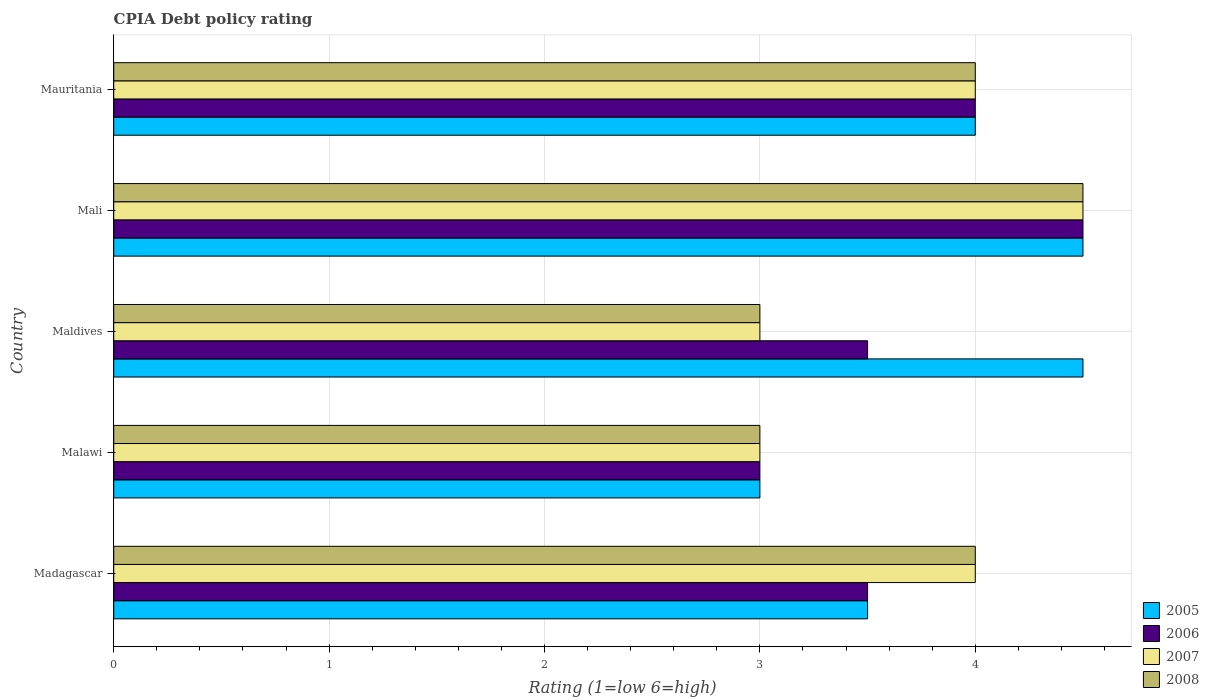How many different coloured bars are there?
Offer a very short reply. 4. What is the label of the 5th group of bars from the top?
Your answer should be compact. Madagascar. In how many cases, is the number of bars for a given country not equal to the number of legend labels?
Offer a very short reply. 0. What is the CPIA rating in 2007 in Malawi?
Your answer should be very brief. 3. Across all countries, what is the minimum CPIA rating in 2006?
Offer a terse response. 3. In which country was the CPIA rating in 2007 maximum?
Your answer should be compact. Mali. In which country was the CPIA rating in 2005 minimum?
Your response must be concise. Malawi. What is the difference between the CPIA rating in 2007 in Malawi and that in Mauritania?
Offer a terse response. -1. What is the difference between the CPIA rating in 2007 in Mauritania and the CPIA rating in 2006 in Maldives?
Make the answer very short. 0.5. What is the average CPIA rating in 2008 per country?
Provide a short and direct response. 3.7. In how many countries, is the CPIA rating in 2008 greater than 1 ?
Offer a terse response. 5. What is the ratio of the CPIA rating in 2007 in Maldives to that in Mauritania?
Give a very brief answer. 0.75. What is the difference between the highest and the lowest CPIA rating in 2008?
Offer a terse response. 1.5. In how many countries, is the CPIA rating in 2007 greater than the average CPIA rating in 2007 taken over all countries?
Your answer should be compact. 3. Is the sum of the CPIA rating in 2006 in Madagascar and Maldives greater than the maximum CPIA rating in 2008 across all countries?
Make the answer very short. Yes. Is it the case that in every country, the sum of the CPIA rating in 2005 and CPIA rating in 2007 is greater than the sum of CPIA rating in 2006 and CPIA rating in 2008?
Your response must be concise. No. What does the 1st bar from the top in Mauritania represents?
Keep it short and to the point. 2008. Is it the case that in every country, the sum of the CPIA rating in 2005 and CPIA rating in 2006 is greater than the CPIA rating in 2008?
Ensure brevity in your answer.  Yes. How many bars are there?
Offer a terse response. 20. How many countries are there in the graph?
Offer a very short reply. 5. What is the difference between two consecutive major ticks on the X-axis?
Your answer should be very brief. 1. Are the values on the major ticks of X-axis written in scientific E-notation?
Provide a succinct answer. No. Where does the legend appear in the graph?
Provide a short and direct response. Bottom right. How are the legend labels stacked?
Your response must be concise. Vertical. What is the title of the graph?
Offer a very short reply. CPIA Debt policy rating. What is the Rating (1=low 6=high) in 2005 in Madagascar?
Give a very brief answer. 3.5. What is the Rating (1=low 6=high) in 2006 in Madagascar?
Offer a very short reply. 3.5. What is the Rating (1=low 6=high) of 2007 in Madagascar?
Make the answer very short. 4. What is the Rating (1=low 6=high) of 2007 in Maldives?
Make the answer very short. 3. What is the Rating (1=low 6=high) in 2008 in Maldives?
Provide a succinct answer. 3. What is the Rating (1=low 6=high) of 2005 in Mali?
Offer a terse response. 4.5. What is the Rating (1=low 6=high) of 2007 in Mali?
Ensure brevity in your answer.  4.5. What is the Rating (1=low 6=high) in 2008 in Mali?
Provide a short and direct response. 4.5. What is the Rating (1=low 6=high) in 2007 in Mauritania?
Offer a very short reply. 4. What is the Rating (1=low 6=high) in 2008 in Mauritania?
Provide a short and direct response. 4. Across all countries, what is the maximum Rating (1=low 6=high) in 2005?
Provide a succinct answer. 4.5. Across all countries, what is the maximum Rating (1=low 6=high) of 2006?
Your answer should be very brief. 4.5. Across all countries, what is the minimum Rating (1=low 6=high) of 2005?
Provide a succinct answer. 3. Across all countries, what is the minimum Rating (1=low 6=high) of 2008?
Your answer should be compact. 3. What is the total Rating (1=low 6=high) of 2006 in the graph?
Offer a very short reply. 18.5. What is the total Rating (1=low 6=high) in 2008 in the graph?
Provide a short and direct response. 18.5. What is the difference between the Rating (1=low 6=high) in 2007 in Madagascar and that in Malawi?
Your answer should be very brief. 1. What is the difference between the Rating (1=low 6=high) in 2007 in Madagascar and that in Maldives?
Make the answer very short. 1. What is the difference between the Rating (1=low 6=high) in 2008 in Madagascar and that in Maldives?
Your answer should be very brief. 1. What is the difference between the Rating (1=low 6=high) of 2006 in Madagascar and that in Mali?
Give a very brief answer. -1. What is the difference between the Rating (1=low 6=high) in 2007 in Madagascar and that in Mali?
Make the answer very short. -0.5. What is the difference between the Rating (1=low 6=high) in 2008 in Madagascar and that in Mali?
Your answer should be very brief. -0.5. What is the difference between the Rating (1=low 6=high) in 2005 in Madagascar and that in Mauritania?
Keep it short and to the point. -0.5. What is the difference between the Rating (1=low 6=high) in 2006 in Madagascar and that in Mauritania?
Provide a succinct answer. -0.5. What is the difference between the Rating (1=low 6=high) in 2007 in Madagascar and that in Mauritania?
Offer a terse response. 0. What is the difference between the Rating (1=low 6=high) in 2005 in Malawi and that in Maldives?
Ensure brevity in your answer.  -1.5. What is the difference between the Rating (1=low 6=high) in 2006 in Malawi and that in Maldives?
Offer a very short reply. -0.5. What is the difference between the Rating (1=low 6=high) of 2007 in Malawi and that in Maldives?
Your answer should be very brief. 0. What is the difference between the Rating (1=low 6=high) in 2008 in Malawi and that in Maldives?
Provide a short and direct response. 0. What is the difference between the Rating (1=low 6=high) in 2005 in Malawi and that in Mali?
Offer a terse response. -1.5. What is the difference between the Rating (1=low 6=high) of 2006 in Malawi and that in Mali?
Provide a short and direct response. -1.5. What is the difference between the Rating (1=low 6=high) of 2007 in Malawi and that in Mali?
Keep it short and to the point. -1.5. What is the difference between the Rating (1=low 6=high) in 2008 in Malawi and that in Mali?
Ensure brevity in your answer.  -1.5. What is the difference between the Rating (1=low 6=high) of 2005 in Malawi and that in Mauritania?
Offer a terse response. -1. What is the difference between the Rating (1=low 6=high) of 2007 in Malawi and that in Mauritania?
Your answer should be very brief. -1. What is the difference between the Rating (1=low 6=high) in 2005 in Maldives and that in Mali?
Your response must be concise. 0. What is the difference between the Rating (1=low 6=high) in 2006 in Maldives and that in Mali?
Your response must be concise. -1. What is the difference between the Rating (1=low 6=high) of 2008 in Maldives and that in Mali?
Your response must be concise. -1.5. What is the difference between the Rating (1=low 6=high) in 2005 in Maldives and that in Mauritania?
Offer a terse response. 0.5. What is the difference between the Rating (1=low 6=high) of 2007 in Maldives and that in Mauritania?
Provide a short and direct response. -1. What is the difference between the Rating (1=low 6=high) in 2005 in Madagascar and the Rating (1=low 6=high) in 2006 in Malawi?
Offer a terse response. 0.5. What is the difference between the Rating (1=low 6=high) of 2005 in Madagascar and the Rating (1=low 6=high) of 2007 in Malawi?
Offer a terse response. 0.5. What is the difference between the Rating (1=low 6=high) of 2005 in Madagascar and the Rating (1=low 6=high) of 2008 in Malawi?
Provide a short and direct response. 0.5. What is the difference between the Rating (1=low 6=high) of 2006 in Madagascar and the Rating (1=low 6=high) of 2007 in Malawi?
Your answer should be compact. 0.5. What is the difference between the Rating (1=low 6=high) in 2005 in Madagascar and the Rating (1=low 6=high) in 2008 in Maldives?
Your response must be concise. 0.5. What is the difference between the Rating (1=low 6=high) in 2006 in Madagascar and the Rating (1=low 6=high) in 2007 in Maldives?
Ensure brevity in your answer.  0.5. What is the difference between the Rating (1=low 6=high) in 2007 in Madagascar and the Rating (1=low 6=high) in 2008 in Maldives?
Offer a terse response. 1. What is the difference between the Rating (1=low 6=high) of 2005 in Madagascar and the Rating (1=low 6=high) of 2007 in Mali?
Your answer should be very brief. -1. What is the difference between the Rating (1=low 6=high) of 2006 in Madagascar and the Rating (1=low 6=high) of 2007 in Mali?
Give a very brief answer. -1. What is the difference between the Rating (1=low 6=high) of 2006 in Madagascar and the Rating (1=low 6=high) of 2008 in Mali?
Offer a terse response. -1. What is the difference between the Rating (1=low 6=high) in 2007 in Madagascar and the Rating (1=low 6=high) in 2008 in Mali?
Your response must be concise. -0.5. What is the difference between the Rating (1=low 6=high) in 2005 in Madagascar and the Rating (1=low 6=high) in 2006 in Mauritania?
Offer a very short reply. -0.5. What is the difference between the Rating (1=low 6=high) of 2005 in Madagascar and the Rating (1=low 6=high) of 2007 in Mauritania?
Provide a short and direct response. -0.5. What is the difference between the Rating (1=low 6=high) in 2005 in Madagascar and the Rating (1=low 6=high) in 2008 in Mauritania?
Offer a terse response. -0.5. What is the difference between the Rating (1=low 6=high) of 2006 in Madagascar and the Rating (1=low 6=high) of 2007 in Mauritania?
Your response must be concise. -0.5. What is the difference between the Rating (1=low 6=high) of 2006 in Madagascar and the Rating (1=low 6=high) of 2008 in Mauritania?
Your answer should be compact. -0.5. What is the difference between the Rating (1=low 6=high) of 2005 in Malawi and the Rating (1=low 6=high) of 2008 in Maldives?
Your answer should be compact. 0. What is the difference between the Rating (1=low 6=high) in 2006 in Malawi and the Rating (1=low 6=high) in 2007 in Maldives?
Give a very brief answer. 0. What is the difference between the Rating (1=low 6=high) of 2007 in Malawi and the Rating (1=low 6=high) of 2008 in Maldives?
Your response must be concise. 0. What is the difference between the Rating (1=low 6=high) in 2005 in Malawi and the Rating (1=low 6=high) in 2006 in Mali?
Your answer should be very brief. -1.5. What is the difference between the Rating (1=low 6=high) of 2005 in Malawi and the Rating (1=low 6=high) of 2007 in Mali?
Your response must be concise. -1.5. What is the difference between the Rating (1=low 6=high) of 2005 in Malawi and the Rating (1=low 6=high) of 2008 in Mali?
Provide a succinct answer. -1.5. What is the difference between the Rating (1=low 6=high) of 2006 in Malawi and the Rating (1=low 6=high) of 2007 in Mali?
Your response must be concise. -1.5. What is the difference between the Rating (1=low 6=high) in 2006 in Malawi and the Rating (1=low 6=high) in 2008 in Mali?
Provide a short and direct response. -1.5. What is the difference between the Rating (1=low 6=high) of 2007 in Malawi and the Rating (1=low 6=high) of 2008 in Mali?
Your answer should be very brief. -1.5. What is the difference between the Rating (1=low 6=high) in 2006 in Malawi and the Rating (1=low 6=high) in 2007 in Mauritania?
Give a very brief answer. -1. What is the difference between the Rating (1=low 6=high) in 2006 in Malawi and the Rating (1=low 6=high) in 2008 in Mauritania?
Offer a very short reply. -1. What is the difference between the Rating (1=low 6=high) in 2007 in Malawi and the Rating (1=low 6=high) in 2008 in Mauritania?
Make the answer very short. -1. What is the difference between the Rating (1=low 6=high) in 2005 in Maldives and the Rating (1=low 6=high) in 2006 in Mali?
Your answer should be compact. 0. What is the difference between the Rating (1=low 6=high) in 2006 in Maldives and the Rating (1=low 6=high) in 2007 in Mali?
Your answer should be compact. -1. What is the difference between the Rating (1=low 6=high) in 2005 in Maldives and the Rating (1=low 6=high) in 2006 in Mauritania?
Your answer should be very brief. 0.5. What is the difference between the Rating (1=low 6=high) in 2005 in Maldives and the Rating (1=low 6=high) in 2007 in Mauritania?
Make the answer very short. 0.5. What is the difference between the Rating (1=low 6=high) of 2005 in Maldives and the Rating (1=low 6=high) of 2008 in Mauritania?
Your answer should be compact. 0.5. What is the difference between the Rating (1=low 6=high) of 2006 in Maldives and the Rating (1=low 6=high) of 2008 in Mauritania?
Your response must be concise. -0.5. What is the difference between the Rating (1=low 6=high) in 2006 in Mali and the Rating (1=low 6=high) in 2007 in Mauritania?
Provide a short and direct response. 0.5. What is the difference between the Rating (1=low 6=high) in 2007 in Mali and the Rating (1=low 6=high) in 2008 in Mauritania?
Ensure brevity in your answer.  0.5. What is the average Rating (1=low 6=high) of 2005 per country?
Provide a short and direct response. 3.9. What is the average Rating (1=low 6=high) of 2007 per country?
Ensure brevity in your answer.  3.7. What is the average Rating (1=low 6=high) of 2008 per country?
Provide a succinct answer. 3.7. What is the difference between the Rating (1=low 6=high) in 2005 and Rating (1=low 6=high) in 2007 in Madagascar?
Your answer should be compact. -0.5. What is the difference between the Rating (1=low 6=high) of 2005 and Rating (1=low 6=high) of 2008 in Madagascar?
Make the answer very short. -0.5. What is the difference between the Rating (1=low 6=high) in 2006 and Rating (1=low 6=high) in 2007 in Madagascar?
Give a very brief answer. -0.5. What is the difference between the Rating (1=low 6=high) of 2007 and Rating (1=low 6=high) of 2008 in Madagascar?
Keep it short and to the point. 0. What is the difference between the Rating (1=low 6=high) of 2005 and Rating (1=low 6=high) of 2006 in Malawi?
Provide a succinct answer. 0. What is the difference between the Rating (1=low 6=high) of 2005 and Rating (1=low 6=high) of 2006 in Maldives?
Keep it short and to the point. 1. What is the difference between the Rating (1=low 6=high) of 2005 and Rating (1=low 6=high) of 2006 in Mali?
Ensure brevity in your answer.  0. What is the difference between the Rating (1=low 6=high) of 2005 and Rating (1=low 6=high) of 2007 in Mali?
Provide a short and direct response. 0. What is the difference between the Rating (1=low 6=high) of 2005 and Rating (1=low 6=high) of 2006 in Mauritania?
Your response must be concise. 0. What is the difference between the Rating (1=low 6=high) of 2005 and Rating (1=low 6=high) of 2008 in Mauritania?
Make the answer very short. 0. What is the ratio of the Rating (1=low 6=high) in 2005 in Madagascar to that in Malawi?
Offer a terse response. 1.17. What is the ratio of the Rating (1=low 6=high) of 2006 in Madagascar to that in Malawi?
Offer a very short reply. 1.17. What is the ratio of the Rating (1=low 6=high) in 2005 in Madagascar to that in Maldives?
Keep it short and to the point. 0.78. What is the ratio of the Rating (1=low 6=high) of 2006 in Madagascar to that in Maldives?
Give a very brief answer. 1. What is the ratio of the Rating (1=low 6=high) of 2007 in Madagascar to that in Maldives?
Make the answer very short. 1.33. What is the ratio of the Rating (1=low 6=high) in 2005 in Madagascar to that in Mali?
Your response must be concise. 0.78. What is the ratio of the Rating (1=low 6=high) in 2006 in Madagascar to that in Mali?
Make the answer very short. 0.78. What is the ratio of the Rating (1=low 6=high) of 2007 in Madagascar to that in Mali?
Your response must be concise. 0.89. What is the ratio of the Rating (1=low 6=high) in 2008 in Madagascar to that in Mali?
Provide a succinct answer. 0.89. What is the ratio of the Rating (1=low 6=high) of 2008 in Madagascar to that in Mauritania?
Keep it short and to the point. 1. What is the ratio of the Rating (1=low 6=high) of 2006 in Malawi to that in Maldives?
Offer a terse response. 0.86. What is the ratio of the Rating (1=low 6=high) of 2008 in Malawi to that in Maldives?
Offer a very short reply. 1. What is the ratio of the Rating (1=low 6=high) of 2005 in Malawi to that in Mali?
Provide a short and direct response. 0.67. What is the ratio of the Rating (1=low 6=high) in 2006 in Malawi to that in Mali?
Provide a succinct answer. 0.67. What is the ratio of the Rating (1=low 6=high) of 2007 in Malawi to that in Mali?
Provide a short and direct response. 0.67. What is the ratio of the Rating (1=low 6=high) of 2008 in Malawi to that in Mali?
Provide a succinct answer. 0.67. What is the ratio of the Rating (1=low 6=high) of 2006 in Malawi to that in Mauritania?
Make the answer very short. 0.75. What is the ratio of the Rating (1=low 6=high) in 2007 in Malawi to that in Mauritania?
Offer a terse response. 0.75. What is the ratio of the Rating (1=low 6=high) in 2006 in Maldives to that in Mali?
Offer a terse response. 0.78. What is the ratio of the Rating (1=low 6=high) in 2007 in Maldives to that in Mali?
Provide a short and direct response. 0.67. What is the ratio of the Rating (1=low 6=high) of 2008 in Maldives to that in Mali?
Keep it short and to the point. 0.67. What is the ratio of the Rating (1=low 6=high) in 2005 in Maldives to that in Mauritania?
Your answer should be very brief. 1.12. What is the ratio of the Rating (1=low 6=high) in 2006 in Maldives to that in Mauritania?
Make the answer very short. 0.88. What is the ratio of the Rating (1=low 6=high) in 2008 in Maldives to that in Mauritania?
Your answer should be compact. 0.75. What is the ratio of the Rating (1=low 6=high) of 2005 in Mali to that in Mauritania?
Give a very brief answer. 1.12. What is the ratio of the Rating (1=low 6=high) of 2008 in Mali to that in Mauritania?
Your response must be concise. 1.12. What is the difference between the highest and the second highest Rating (1=low 6=high) of 2007?
Keep it short and to the point. 0.5. What is the difference between the highest and the second highest Rating (1=low 6=high) of 2008?
Ensure brevity in your answer.  0.5. What is the difference between the highest and the lowest Rating (1=low 6=high) of 2007?
Provide a short and direct response. 1.5. 